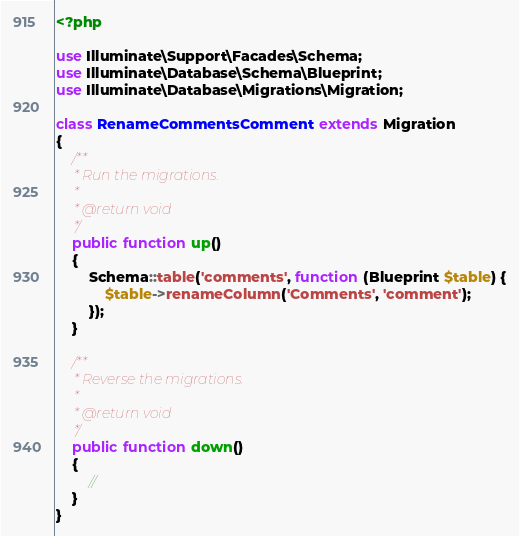Convert code to text. <code><loc_0><loc_0><loc_500><loc_500><_PHP_><?php

use Illuminate\Support\Facades\Schema;
use Illuminate\Database\Schema\Blueprint;
use Illuminate\Database\Migrations\Migration;

class RenameCommentsComment extends Migration
{
    /**
     * Run the migrations.
     *
     * @return void
     */
    public function up()
    {
        Schema::table('comments', function (Blueprint $table) {
            $table->renameColumn('Comments', 'comment');
        });
    }

    /**
     * Reverse the migrations.
     *
     * @return void
     */
    public function down()
    {
        //
    }
}
</code> 